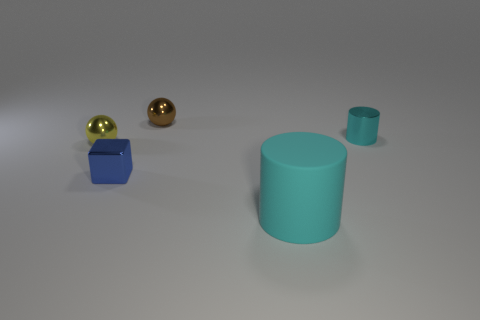Subtract all cylinders. How many objects are left? 3 Add 1 tiny metal spheres. How many objects exist? 6 Add 5 tiny shiny objects. How many tiny shiny objects exist? 9 Subtract 0 green spheres. How many objects are left? 5 Subtract all large purple balls. Subtract all spheres. How many objects are left? 3 Add 5 tiny brown objects. How many tiny brown objects are left? 6 